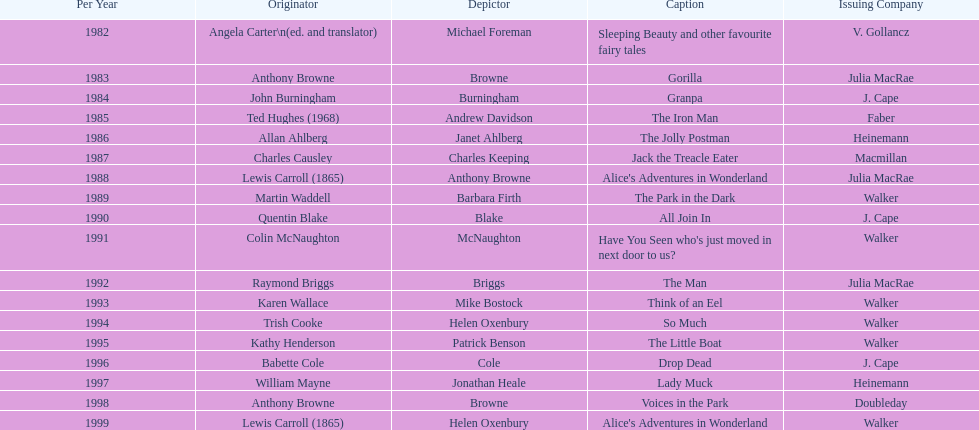Which illustrator was responsible for the last award winner? Helen Oxenbury. 